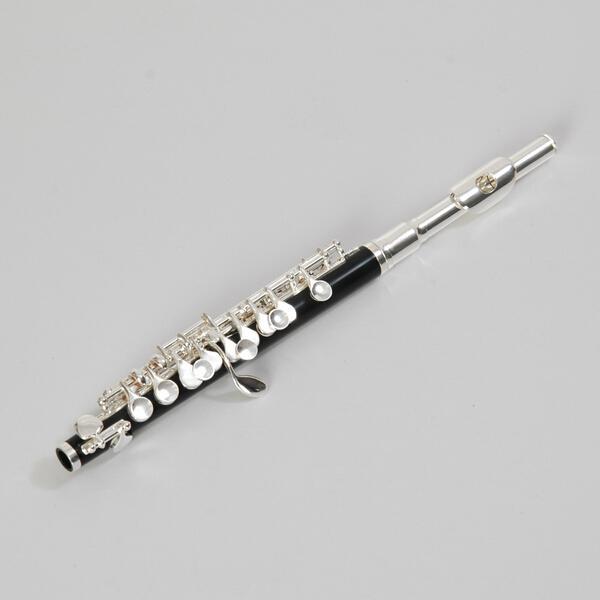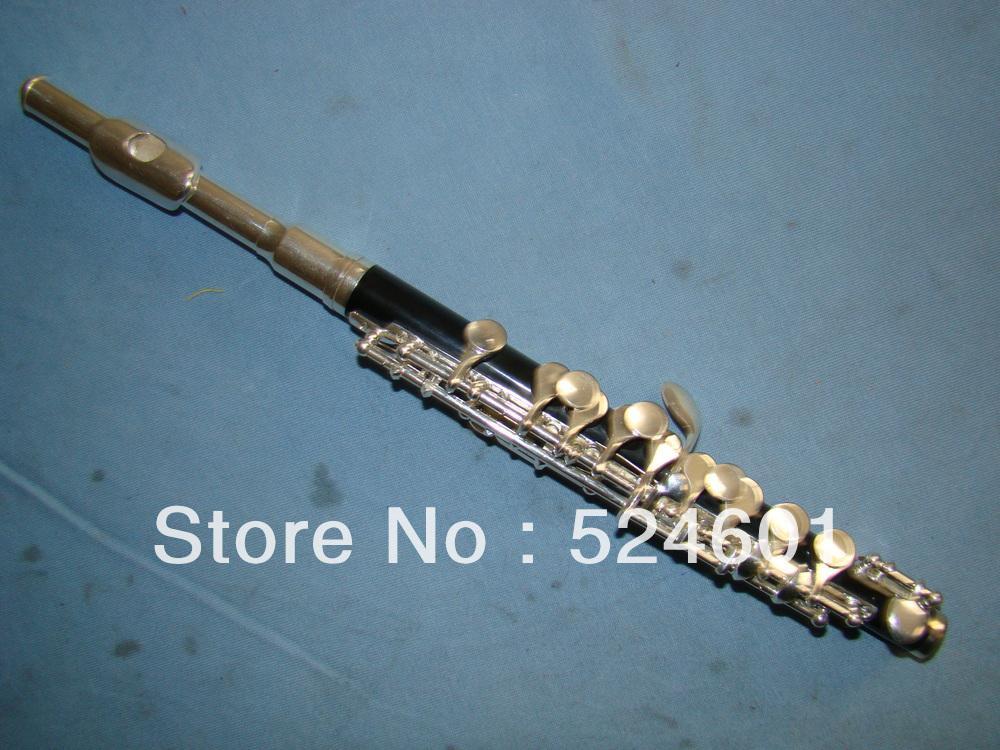The first image is the image on the left, the second image is the image on the right. Given the left and right images, does the statement "Exactly two mouthpieces are visible." hold true? Answer yes or no. Yes. 